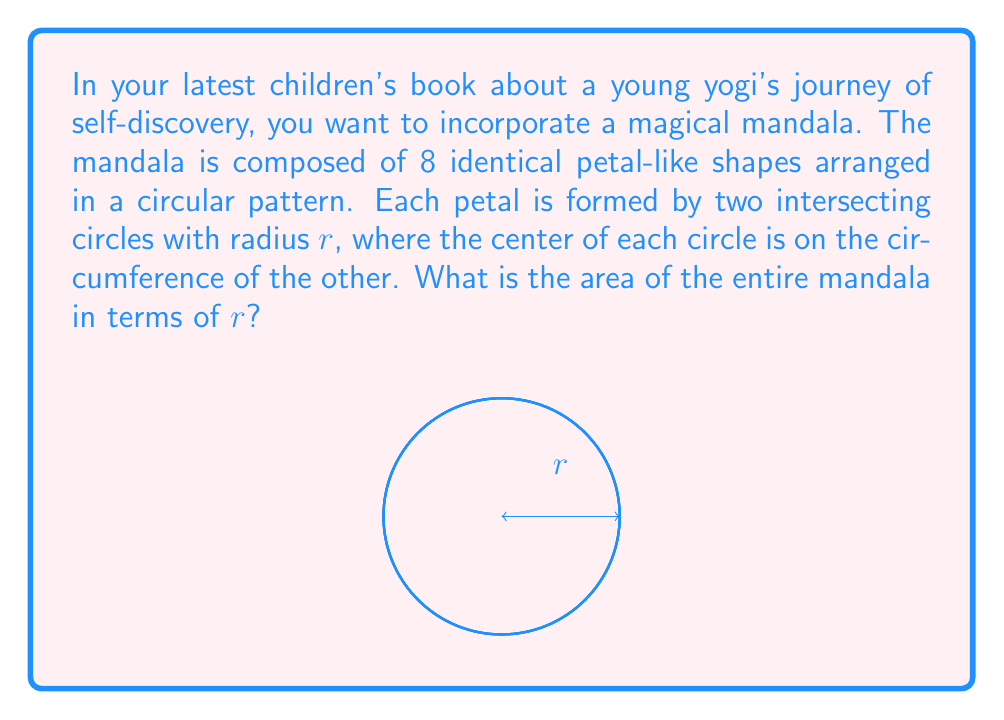Help me with this question. Let's approach this step-by-step:

1) First, we need to find the area of a single petal. This shape is known as a vesica piscis.

2) The area of a vesica piscis is given by the formula:

   $$A_{petal} = r^2 (\pi/3 - \sqrt{3}/4)$$

3) Our mandala consists of 8 of these petals, so we multiply this area by 8:

   $$A_{mandala} = 8r^2 (\pi/3 - \sqrt{3}/4)$$

4) Simplifying:

   $$A_{mandala} = r^2 (8\pi/3 - 2\sqrt{3})$$

5) This can be further simplified to:

   $$A_{mandala} = r^2 (\frac{8\pi}{3} - 2\sqrt{3})$$

This formula gives us the area of the entire mandala in terms of $r$.
Answer: $r^2 (\frac{8\pi}{3} - 2\sqrt{3})$ 